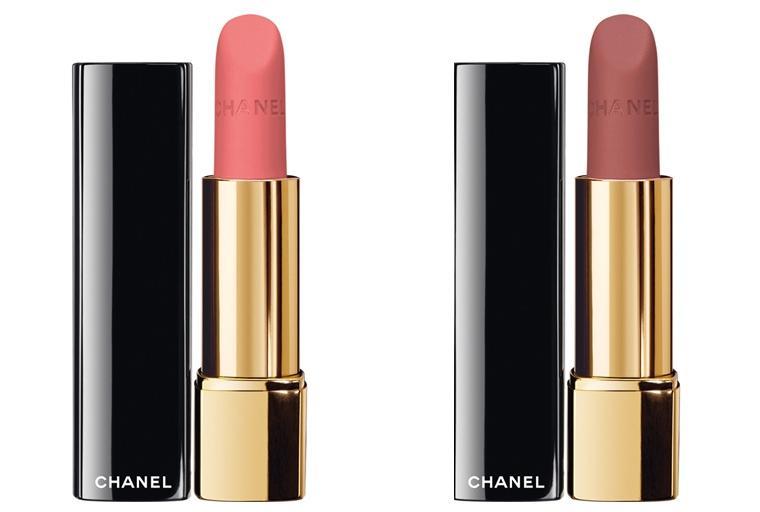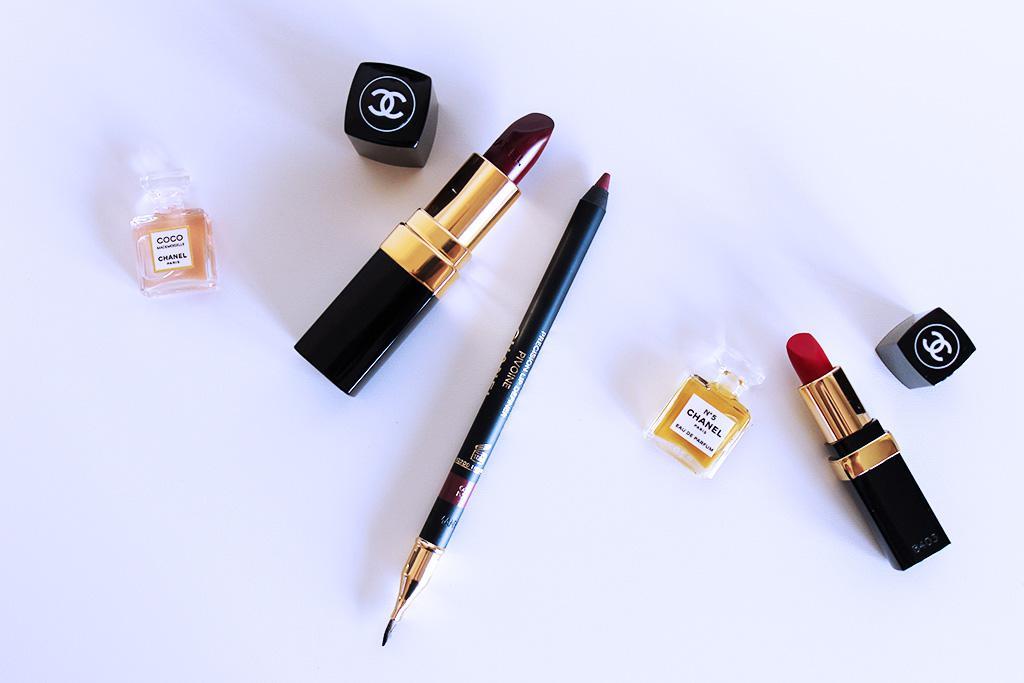The first image is the image on the left, the second image is the image on the right. Assess this claim about the two images: "An image with a lip pencil and lipstick includes a creamy colored flower.". Correct or not? Answer yes or no. No. The first image is the image on the left, the second image is the image on the right. Examine the images to the left and right. Is the description "There is one tube of lipstick in each of the images." accurate? Answer yes or no. No. 